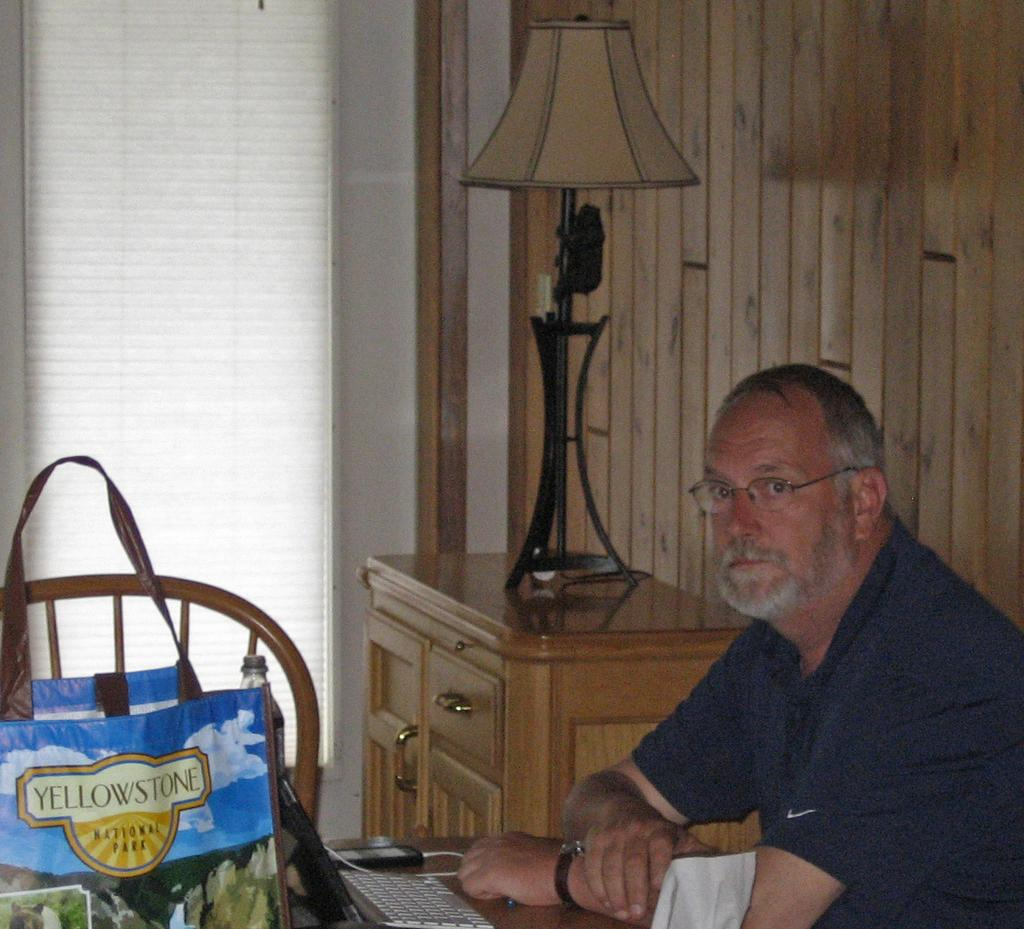What is the man in the image doing? The man is sitting in the image. What object can be seen near the man? There is a bag in the image. What device is visible in the image? There is a keyboard in the image. What is on the table in the image? There is a bottle on a table in the image. What type of furniture is present in the background of the image? There is a cupboard in the background of the image. What light source is visible in the background of the image? There is a lamp in the background of the image. What type of wall can be seen in the background of the image? There is a wooden wall in the background of the image. What architectural feature is present in the background of the image? There is a window in the background of the image. What color of paint is being used to create the selection of facts in the image? There is no paint or selection of facts present in the image; it is a photograph or digital representation of a scene. 